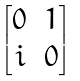Convert formula to latex. <formula><loc_0><loc_0><loc_500><loc_500>\begin{bmatrix} 0 & 1 \\ i & 0 \end{bmatrix}</formula> 